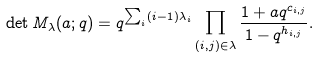Convert formula to latex. <formula><loc_0><loc_0><loc_500><loc_500>\det M _ { \lambda } ( a ; q ) = q ^ { \sum _ { i } ( i - 1 ) \lambda _ { i } } \prod _ { ( i , j ) \in \lambda } \frac { 1 + a q ^ { c _ { i , j } } } { 1 - q ^ { h _ { i , j } } } .</formula> 